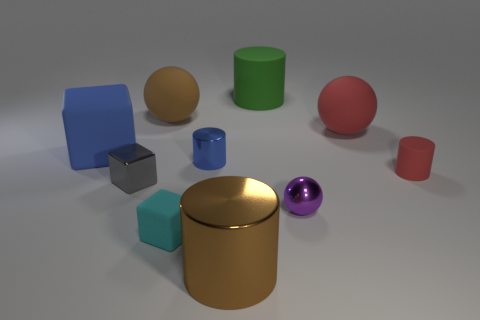The small shiny block has what color?
Provide a succinct answer. Gray. What is the size of the cylinder that is both behind the red cylinder and left of the green matte cylinder?
Offer a terse response. Small. Does the small shiny thing that is in front of the gray cube have the same shape as the large thing that is to the right of the big green cylinder?
Provide a succinct answer. Yes. What shape is the large object that is the same color as the small matte cylinder?
Provide a succinct answer. Sphere. How many small brown cubes are made of the same material as the green object?
Ensure brevity in your answer.  0. The small object that is both behind the small metal cube and on the left side of the red sphere has what shape?
Offer a terse response. Cylinder. Does the large cylinder that is to the left of the green thing have the same material as the small cyan thing?
Provide a succinct answer. No. There is another block that is the same size as the gray metal cube; what color is it?
Offer a very short reply. Cyan. Is there a small metal object that has the same color as the large matte cube?
Ensure brevity in your answer.  Yes. What size is the brown object that is the same material as the purple object?
Make the answer very short. Large. 